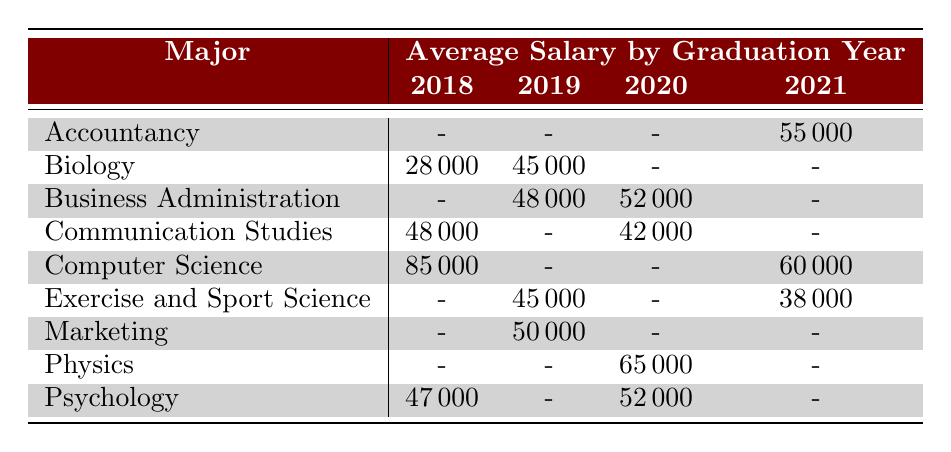What was the average salary for Computer Science graduates in 2018? The table shows that the average salary for Computer Science graduates in 2018 is 85000.
Answer: 85000 What is the employment status of Biology graduates in 2020? The table does not list any Biology graduates in 2020, so there is no employment status provided.
Answer: No data Which major has the highest average salary in 2018? By looking at the table, the only major listed in 2018 is Computer Science with an average salary of 85000, which is the highest among other majors in that year.
Answer: Computer Science What is the difference in average salary between Psychology graduates in 2018 and 2020? The average salary for Psychology graduates in 2018 is 47000 and in 2020 is 52000. The difference is 52000 - 47000 = 5000.
Answer: 5000 Did any Exercise and Sport Science graduates get a job in 2018? The table indicates that there are no Exercise and Sport Science graduates listed for 2018, hence no graduates got jobs that year.
Answer: No What is the average salary for Business Administration graduates overall? The table shows Business Administration graduates' salaries as follows: 48000 in 2019 and 52000 in 2020. To find the average, calculate (48000 + 52000) / 2 = 50000.
Answer: 50000 Is there any year when Accounting graduates were employed? The table shows that there is no entry for Accountancy graduates employed before 2021, which means there were no employed Accounting graduates in the earlier years.
Answer: No Which major had the lowest average salary in 2021? The only listed salaries for 2021 are: Accountancy (55000), Exercise and Sport Science (38000), and Computer Science (60000). The lowest is 38000 for Exercise and Sport Science.
Answer: Exercise and Sport Science What was the average salary of graduates who majored in Communication Studies? The table shows that Communication Studies graduates earned 48000 in 2018 and 42000 in 2020. Therefore, their average salary is (48000 + 42000) / 2 = 45000.
Answer: 45000 